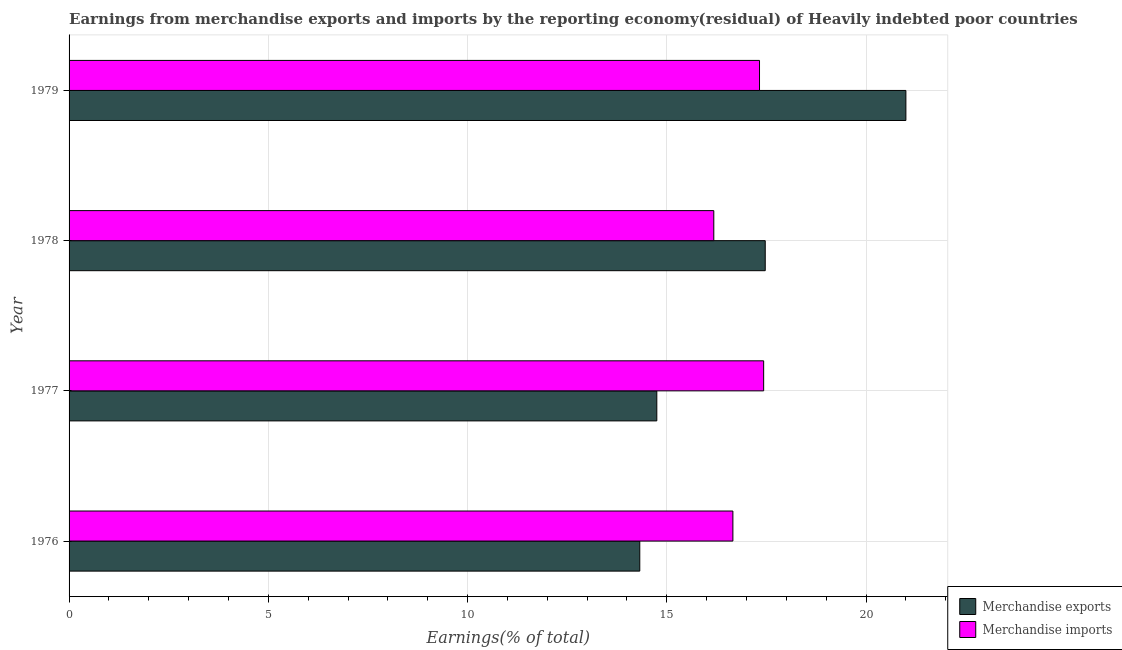How many groups of bars are there?
Offer a terse response. 4. Are the number of bars per tick equal to the number of legend labels?
Provide a succinct answer. Yes. How many bars are there on the 2nd tick from the bottom?
Offer a very short reply. 2. What is the label of the 1st group of bars from the top?
Provide a short and direct response. 1979. In how many cases, is the number of bars for a given year not equal to the number of legend labels?
Provide a succinct answer. 0. What is the earnings from merchandise imports in 1978?
Make the answer very short. 16.18. Across all years, what is the maximum earnings from merchandise imports?
Your answer should be compact. 17.43. Across all years, what is the minimum earnings from merchandise exports?
Your answer should be very brief. 14.32. In which year was the earnings from merchandise exports maximum?
Make the answer very short. 1979. In which year was the earnings from merchandise imports minimum?
Your response must be concise. 1978. What is the total earnings from merchandise exports in the graph?
Provide a succinct answer. 67.54. What is the difference between the earnings from merchandise imports in 1977 and that in 1978?
Your response must be concise. 1.25. What is the difference between the earnings from merchandise imports in 1979 and the earnings from merchandise exports in 1977?
Keep it short and to the point. 2.58. What is the average earnings from merchandise imports per year?
Your answer should be very brief. 16.9. In the year 1979, what is the difference between the earnings from merchandise imports and earnings from merchandise exports?
Give a very brief answer. -3.67. In how many years, is the earnings from merchandise imports greater than 20 %?
Your answer should be very brief. 0. What is the ratio of the earnings from merchandise imports in 1976 to that in 1979?
Your answer should be very brief. 0.96. Is the earnings from merchandise exports in 1977 less than that in 1979?
Your answer should be compact. Yes. What is the difference between the highest and the second highest earnings from merchandise exports?
Your answer should be very brief. 3.53. What is the difference between the highest and the lowest earnings from merchandise exports?
Provide a succinct answer. 6.68. Is the sum of the earnings from merchandise exports in 1978 and 1979 greater than the maximum earnings from merchandise imports across all years?
Make the answer very short. Yes. What does the 1st bar from the top in 1978 represents?
Provide a succinct answer. Merchandise imports. How many bars are there?
Ensure brevity in your answer.  8. Are all the bars in the graph horizontal?
Ensure brevity in your answer.  Yes. What is the difference between two consecutive major ticks on the X-axis?
Your answer should be compact. 5. Does the graph contain any zero values?
Your answer should be very brief. No. Does the graph contain grids?
Offer a very short reply. Yes. Where does the legend appear in the graph?
Keep it short and to the point. Bottom right. How many legend labels are there?
Keep it short and to the point. 2. How are the legend labels stacked?
Your response must be concise. Vertical. What is the title of the graph?
Make the answer very short. Earnings from merchandise exports and imports by the reporting economy(residual) of Heavily indebted poor countries. What is the label or title of the X-axis?
Provide a succinct answer. Earnings(% of total). What is the label or title of the Y-axis?
Give a very brief answer. Year. What is the Earnings(% of total) of Merchandise exports in 1976?
Provide a succinct answer. 14.32. What is the Earnings(% of total) in Merchandise imports in 1976?
Make the answer very short. 16.66. What is the Earnings(% of total) of Merchandise exports in 1977?
Provide a succinct answer. 14.75. What is the Earnings(% of total) of Merchandise imports in 1977?
Your answer should be compact. 17.43. What is the Earnings(% of total) in Merchandise exports in 1978?
Provide a succinct answer. 17.47. What is the Earnings(% of total) of Merchandise imports in 1978?
Make the answer very short. 16.18. What is the Earnings(% of total) of Merchandise exports in 1979?
Offer a terse response. 21. What is the Earnings(% of total) in Merchandise imports in 1979?
Provide a short and direct response. 17.33. Across all years, what is the maximum Earnings(% of total) in Merchandise exports?
Keep it short and to the point. 21. Across all years, what is the maximum Earnings(% of total) of Merchandise imports?
Your answer should be compact. 17.43. Across all years, what is the minimum Earnings(% of total) of Merchandise exports?
Offer a terse response. 14.32. Across all years, what is the minimum Earnings(% of total) of Merchandise imports?
Provide a succinct answer. 16.18. What is the total Earnings(% of total) in Merchandise exports in the graph?
Keep it short and to the point. 67.54. What is the total Earnings(% of total) of Merchandise imports in the graph?
Make the answer very short. 67.59. What is the difference between the Earnings(% of total) in Merchandise exports in 1976 and that in 1977?
Ensure brevity in your answer.  -0.43. What is the difference between the Earnings(% of total) of Merchandise imports in 1976 and that in 1977?
Your answer should be compact. -0.77. What is the difference between the Earnings(% of total) in Merchandise exports in 1976 and that in 1978?
Ensure brevity in your answer.  -3.15. What is the difference between the Earnings(% of total) of Merchandise imports in 1976 and that in 1978?
Your answer should be very brief. 0.48. What is the difference between the Earnings(% of total) of Merchandise exports in 1976 and that in 1979?
Your answer should be compact. -6.68. What is the difference between the Earnings(% of total) of Merchandise imports in 1976 and that in 1979?
Ensure brevity in your answer.  -0.67. What is the difference between the Earnings(% of total) of Merchandise exports in 1977 and that in 1978?
Offer a very short reply. -2.72. What is the difference between the Earnings(% of total) of Merchandise imports in 1977 and that in 1978?
Keep it short and to the point. 1.25. What is the difference between the Earnings(% of total) in Merchandise exports in 1977 and that in 1979?
Keep it short and to the point. -6.25. What is the difference between the Earnings(% of total) of Merchandise imports in 1977 and that in 1979?
Give a very brief answer. 0.1. What is the difference between the Earnings(% of total) of Merchandise exports in 1978 and that in 1979?
Your answer should be very brief. -3.53. What is the difference between the Earnings(% of total) in Merchandise imports in 1978 and that in 1979?
Give a very brief answer. -1.15. What is the difference between the Earnings(% of total) in Merchandise exports in 1976 and the Earnings(% of total) in Merchandise imports in 1977?
Your response must be concise. -3.11. What is the difference between the Earnings(% of total) in Merchandise exports in 1976 and the Earnings(% of total) in Merchandise imports in 1978?
Your answer should be very brief. -1.86. What is the difference between the Earnings(% of total) of Merchandise exports in 1976 and the Earnings(% of total) of Merchandise imports in 1979?
Provide a short and direct response. -3. What is the difference between the Earnings(% of total) of Merchandise exports in 1977 and the Earnings(% of total) of Merchandise imports in 1978?
Give a very brief answer. -1.43. What is the difference between the Earnings(% of total) in Merchandise exports in 1977 and the Earnings(% of total) in Merchandise imports in 1979?
Ensure brevity in your answer.  -2.58. What is the difference between the Earnings(% of total) in Merchandise exports in 1978 and the Earnings(% of total) in Merchandise imports in 1979?
Make the answer very short. 0.14. What is the average Earnings(% of total) of Merchandise exports per year?
Make the answer very short. 16.88. What is the average Earnings(% of total) of Merchandise imports per year?
Provide a short and direct response. 16.9. In the year 1976, what is the difference between the Earnings(% of total) in Merchandise exports and Earnings(% of total) in Merchandise imports?
Give a very brief answer. -2.34. In the year 1977, what is the difference between the Earnings(% of total) in Merchandise exports and Earnings(% of total) in Merchandise imports?
Keep it short and to the point. -2.68. In the year 1978, what is the difference between the Earnings(% of total) in Merchandise exports and Earnings(% of total) in Merchandise imports?
Give a very brief answer. 1.29. In the year 1979, what is the difference between the Earnings(% of total) of Merchandise exports and Earnings(% of total) of Merchandise imports?
Give a very brief answer. 3.67. What is the ratio of the Earnings(% of total) of Merchandise exports in 1976 to that in 1977?
Offer a very short reply. 0.97. What is the ratio of the Earnings(% of total) in Merchandise imports in 1976 to that in 1977?
Ensure brevity in your answer.  0.96. What is the ratio of the Earnings(% of total) in Merchandise exports in 1976 to that in 1978?
Keep it short and to the point. 0.82. What is the ratio of the Earnings(% of total) of Merchandise imports in 1976 to that in 1978?
Your answer should be very brief. 1.03. What is the ratio of the Earnings(% of total) in Merchandise exports in 1976 to that in 1979?
Make the answer very short. 0.68. What is the ratio of the Earnings(% of total) of Merchandise imports in 1976 to that in 1979?
Your answer should be compact. 0.96. What is the ratio of the Earnings(% of total) of Merchandise exports in 1977 to that in 1978?
Your answer should be very brief. 0.84. What is the ratio of the Earnings(% of total) of Merchandise imports in 1977 to that in 1978?
Provide a succinct answer. 1.08. What is the ratio of the Earnings(% of total) of Merchandise exports in 1977 to that in 1979?
Keep it short and to the point. 0.7. What is the ratio of the Earnings(% of total) in Merchandise exports in 1978 to that in 1979?
Offer a very short reply. 0.83. What is the ratio of the Earnings(% of total) in Merchandise imports in 1978 to that in 1979?
Provide a short and direct response. 0.93. What is the difference between the highest and the second highest Earnings(% of total) of Merchandise exports?
Your answer should be compact. 3.53. What is the difference between the highest and the second highest Earnings(% of total) in Merchandise imports?
Make the answer very short. 0.1. What is the difference between the highest and the lowest Earnings(% of total) in Merchandise exports?
Your response must be concise. 6.68. What is the difference between the highest and the lowest Earnings(% of total) of Merchandise imports?
Give a very brief answer. 1.25. 